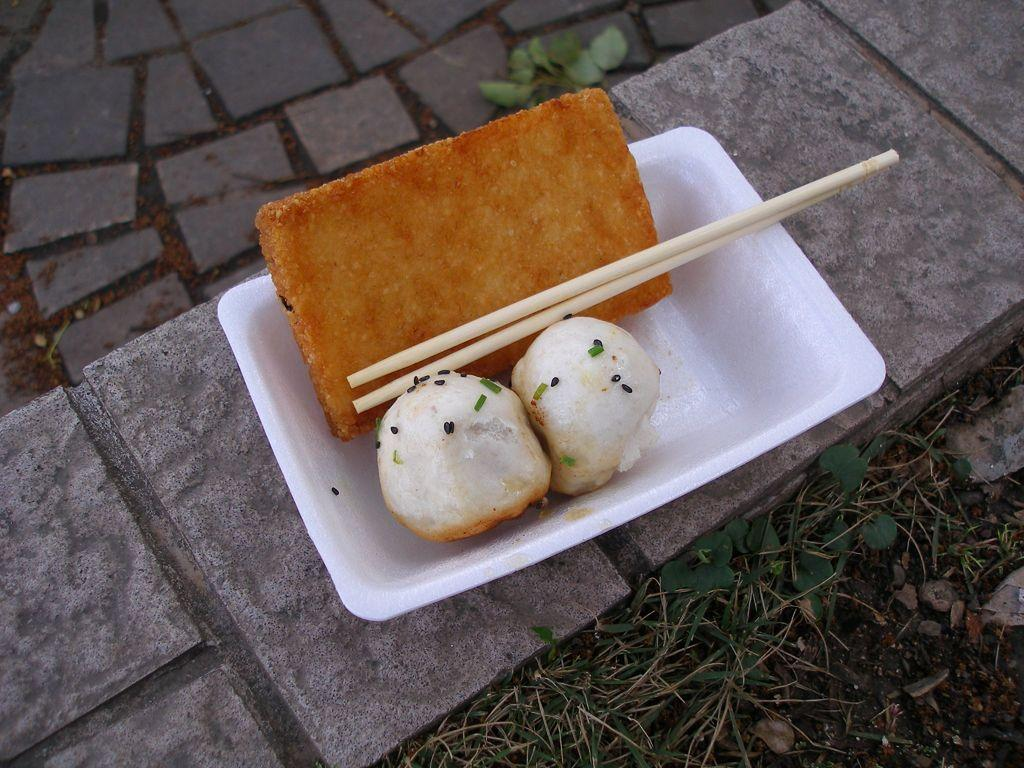What type of living organisms can be seen in the image? Plants are visible in the image. What other objects can be seen in the image? Stones and a white bowl with food items are present in the image. What utensils are in the white bowl? Chopsticks are present in the white bowl. Where is the white bowl placed? The white bowl is placed on a surface. How many ladybugs are crawling on the corn in the image? There is no corn or ladybugs present in the image. 